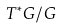Convert formula to latex. <formula><loc_0><loc_0><loc_500><loc_500>T ^ { * } G / G</formula> 